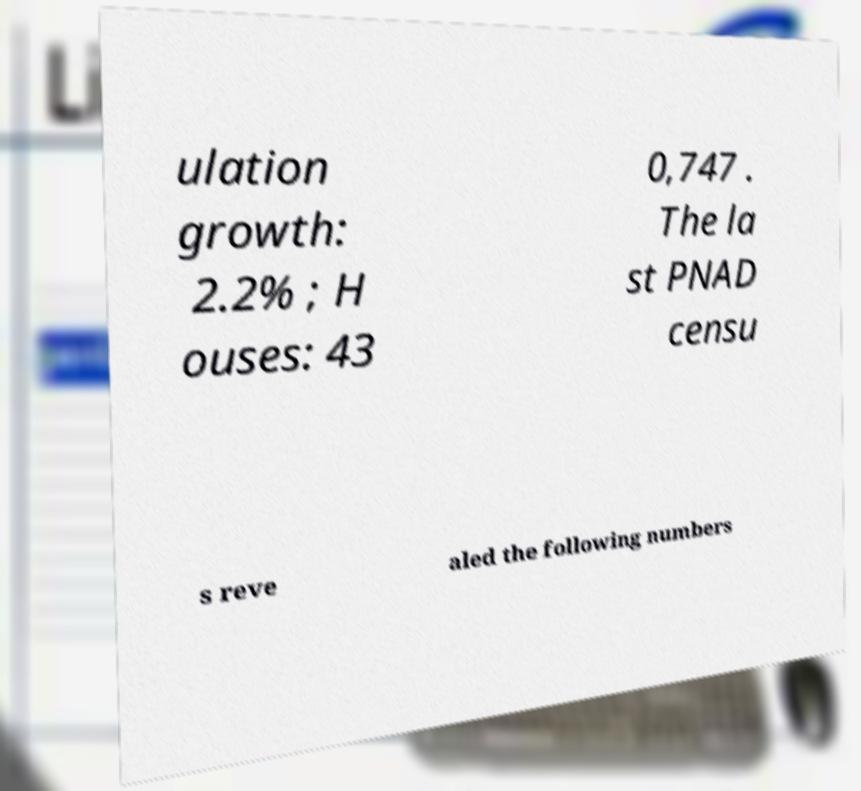Could you extract and type out the text from this image? ulation growth: 2.2% ; H ouses: 43 0,747 . The la st PNAD censu s reve aled the following numbers 